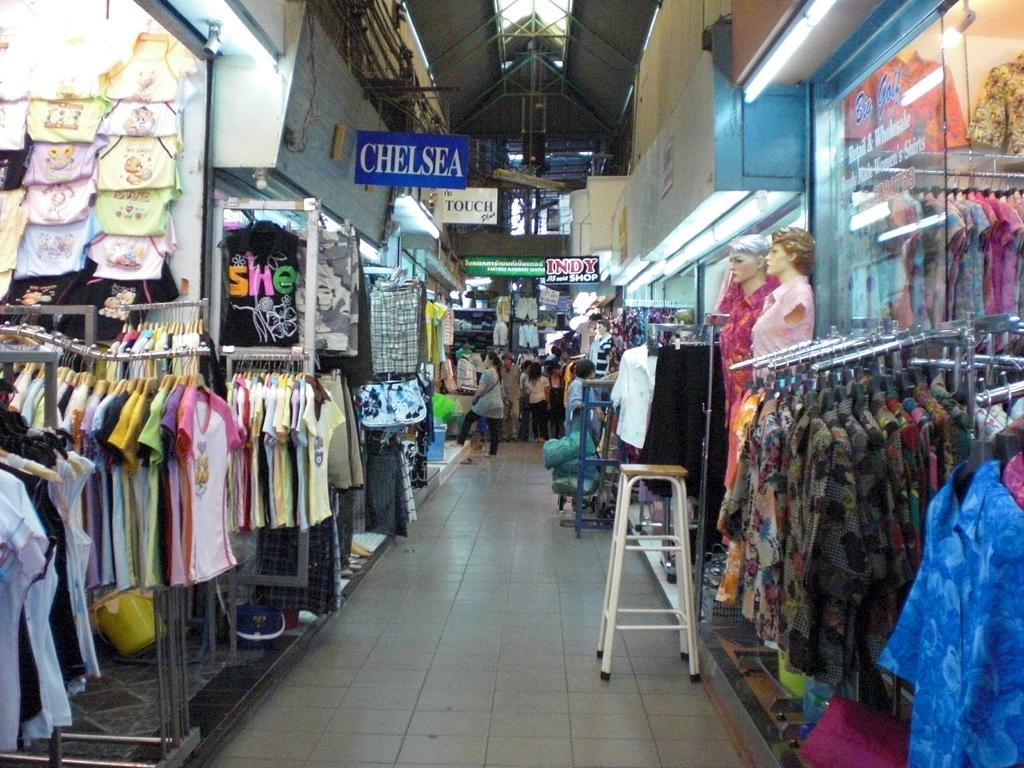<image>
Give a short and clear explanation of the subsequent image. An aisle in a store contains lots of clothes under a sign that says Chelsea. 